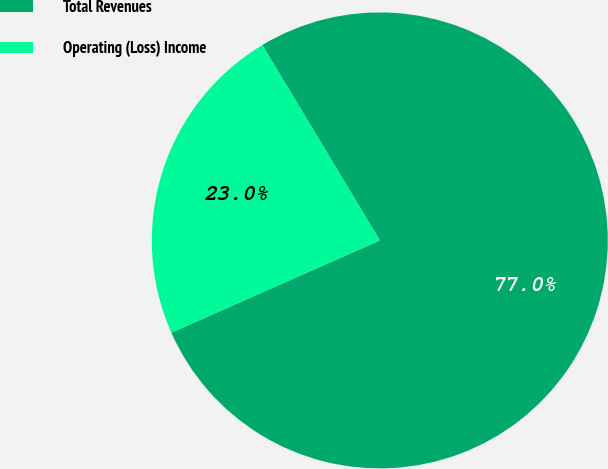Convert chart to OTSL. <chart><loc_0><loc_0><loc_500><loc_500><pie_chart><fcel>Total Revenues<fcel>Operating (Loss) Income<nl><fcel>76.99%<fcel>23.01%<nl></chart> 